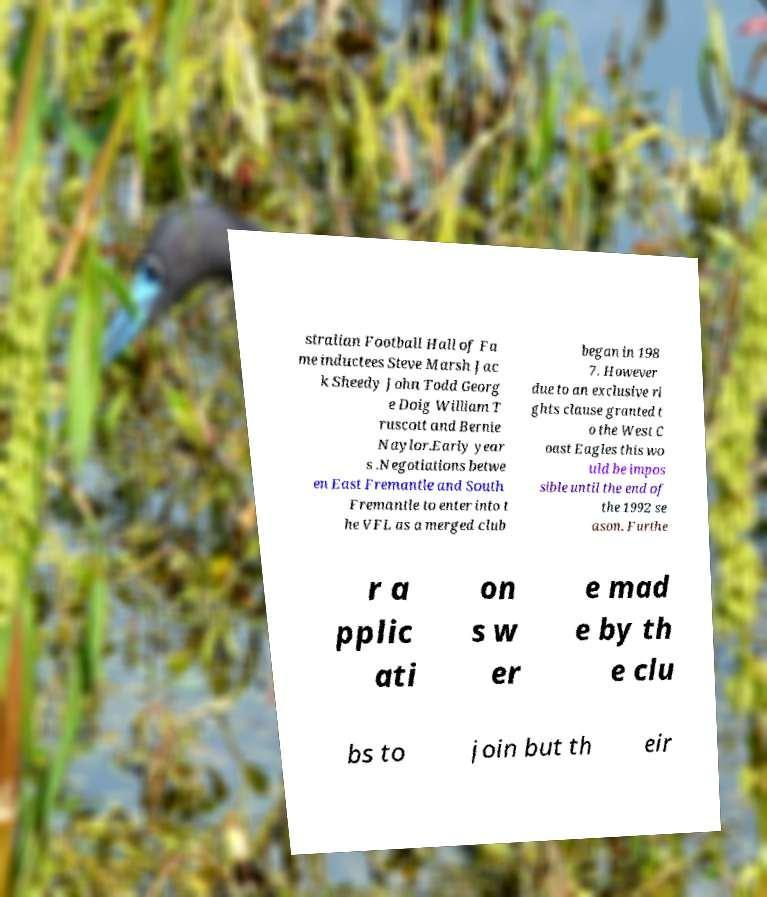For documentation purposes, I need the text within this image transcribed. Could you provide that? stralian Football Hall of Fa me inductees Steve Marsh Jac k Sheedy John Todd Georg e Doig William T ruscott and Bernie Naylor.Early year s .Negotiations betwe en East Fremantle and South Fremantle to enter into t he VFL as a merged club began in 198 7. However due to an exclusive ri ghts clause granted t o the West C oast Eagles this wo uld be impos sible until the end of the 1992 se ason. Furthe r a pplic ati on s w er e mad e by th e clu bs to join but th eir 